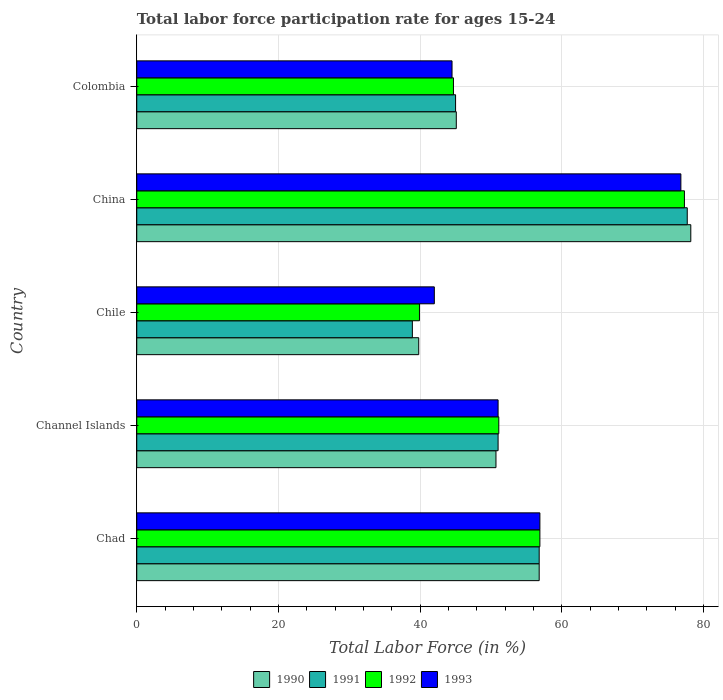How many different coloured bars are there?
Offer a terse response. 4. How many groups of bars are there?
Provide a succinct answer. 5. Are the number of bars per tick equal to the number of legend labels?
Provide a succinct answer. Yes. How many bars are there on the 4th tick from the top?
Offer a very short reply. 4. What is the label of the 5th group of bars from the top?
Ensure brevity in your answer.  Chad. What is the labor force participation rate in 1992 in Chad?
Make the answer very short. 56.9. Across all countries, what is the maximum labor force participation rate in 1991?
Provide a short and direct response. 77.7. Across all countries, what is the minimum labor force participation rate in 1992?
Your answer should be very brief. 39.9. In which country was the labor force participation rate in 1993 maximum?
Ensure brevity in your answer.  China. What is the total labor force participation rate in 1990 in the graph?
Make the answer very short. 270.6. What is the difference between the labor force participation rate in 1990 in Chad and that in Channel Islands?
Your answer should be compact. 6.1. What is the difference between the labor force participation rate in 1990 in Chad and the labor force participation rate in 1992 in Channel Islands?
Make the answer very short. 5.7. What is the average labor force participation rate in 1992 per country?
Your response must be concise. 53.98. What is the difference between the labor force participation rate in 1990 and labor force participation rate in 1992 in China?
Provide a succinct answer. 0.9. In how many countries, is the labor force participation rate in 1991 greater than 24 %?
Offer a terse response. 5. What is the ratio of the labor force participation rate in 1991 in Chad to that in Chile?
Ensure brevity in your answer.  1.46. Is the difference between the labor force participation rate in 1990 in Chile and China greater than the difference between the labor force participation rate in 1992 in Chile and China?
Give a very brief answer. No. What is the difference between the highest and the second highest labor force participation rate in 1991?
Keep it short and to the point. 20.9. What is the difference between the highest and the lowest labor force participation rate in 1991?
Your answer should be compact. 38.8. Is it the case that in every country, the sum of the labor force participation rate in 1990 and labor force participation rate in 1992 is greater than the sum of labor force participation rate in 1991 and labor force participation rate in 1993?
Give a very brief answer. No. What does the 2nd bar from the top in Colombia represents?
Your answer should be compact. 1992. What does the 1st bar from the bottom in Channel Islands represents?
Keep it short and to the point. 1990. How many bars are there?
Give a very brief answer. 20. Are all the bars in the graph horizontal?
Provide a short and direct response. Yes. How many countries are there in the graph?
Provide a short and direct response. 5. What is the difference between two consecutive major ticks on the X-axis?
Ensure brevity in your answer.  20. Does the graph contain grids?
Your answer should be compact. Yes. How many legend labels are there?
Offer a very short reply. 4. What is the title of the graph?
Give a very brief answer. Total labor force participation rate for ages 15-24. What is the Total Labor Force (in %) of 1990 in Chad?
Ensure brevity in your answer.  56.8. What is the Total Labor Force (in %) in 1991 in Chad?
Give a very brief answer. 56.8. What is the Total Labor Force (in %) of 1992 in Chad?
Provide a succinct answer. 56.9. What is the Total Labor Force (in %) of 1993 in Chad?
Ensure brevity in your answer.  56.9. What is the Total Labor Force (in %) of 1990 in Channel Islands?
Offer a very short reply. 50.7. What is the Total Labor Force (in %) in 1991 in Channel Islands?
Your response must be concise. 51. What is the Total Labor Force (in %) of 1992 in Channel Islands?
Ensure brevity in your answer.  51.1. What is the Total Labor Force (in %) of 1990 in Chile?
Your response must be concise. 39.8. What is the Total Labor Force (in %) in 1991 in Chile?
Offer a terse response. 38.9. What is the Total Labor Force (in %) of 1992 in Chile?
Your answer should be compact. 39.9. What is the Total Labor Force (in %) in 1993 in Chile?
Your answer should be compact. 42. What is the Total Labor Force (in %) in 1990 in China?
Offer a terse response. 78.2. What is the Total Labor Force (in %) of 1991 in China?
Your response must be concise. 77.7. What is the Total Labor Force (in %) in 1992 in China?
Ensure brevity in your answer.  77.3. What is the Total Labor Force (in %) of 1993 in China?
Offer a terse response. 76.8. What is the Total Labor Force (in %) in 1990 in Colombia?
Ensure brevity in your answer.  45.1. What is the Total Labor Force (in %) in 1991 in Colombia?
Offer a terse response. 45. What is the Total Labor Force (in %) of 1992 in Colombia?
Your answer should be compact. 44.7. What is the Total Labor Force (in %) of 1993 in Colombia?
Provide a short and direct response. 44.5. Across all countries, what is the maximum Total Labor Force (in %) in 1990?
Your answer should be compact. 78.2. Across all countries, what is the maximum Total Labor Force (in %) of 1991?
Your response must be concise. 77.7. Across all countries, what is the maximum Total Labor Force (in %) in 1992?
Make the answer very short. 77.3. Across all countries, what is the maximum Total Labor Force (in %) in 1993?
Your answer should be very brief. 76.8. Across all countries, what is the minimum Total Labor Force (in %) in 1990?
Your answer should be compact. 39.8. Across all countries, what is the minimum Total Labor Force (in %) of 1991?
Provide a succinct answer. 38.9. Across all countries, what is the minimum Total Labor Force (in %) of 1992?
Offer a very short reply. 39.9. What is the total Total Labor Force (in %) of 1990 in the graph?
Ensure brevity in your answer.  270.6. What is the total Total Labor Force (in %) in 1991 in the graph?
Provide a succinct answer. 269.4. What is the total Total Labor Force (in %) of 1992 in the graph?
Give a very brief answer. 269.9. What is the total Total Labor Force (in %) of 1993 in the graph?
Your response must be concise. 271.2. What is the difference between the Total Labor Force (in %) in 1990 in Chad and that in Channel Islands?
Provide a succinct answer. 6.1. What is the difference between the Total Labor Force (in %) in 1991 in Chad and that in Channel Islands?
Provide a short and direct response. 5.8. What is the difference between the Total Labor Force (in %) in 1992 in Chad and that in Channel Islands?
Your response must be concise. 5.8. What is the difference between the Total Labor Force (in %) in 1993 in Chad and that in Channel Islands?
Your answer should be compact. 5.9. What is the difference between the Total Labor Force (in %) of 1990 in Chad and that in Chile?
Your response must be concise. 17. What is the difference between the Total Labor Force (in %) in 1991 in Chad and that in Chile?
Keep it short and to the point. 17.9. What is the difference between the Total Labor Force (in %) in 1993 in Chad and that in Chile?
Offer a very short reply. 14.9. What is the difference between the Total Labor Force (in %) in 1990 in Chad and that in China?
Your answer should be very brief. -21.4. What is the difference between the Total Labor Force (in %) in 1991 in Chad and that in China?
Offer a terse response. -20.9. What is the difference between the Total Labor Force (in %) in 1992 in Chad and that in China?
Ensure brevity in your answer.  -20.4. What is the difference between the Total Labor Force (in %) in 1993 in Chad and that in China?
Provide a succinct answer. -19.9. What is the difference between the Total Labor Force (in %) in 1990 in Chad and that in Colombia?
Provide a short and direct response. 11.7. What is the difference between the Total Labor Force (in %) of 1992 in Chad and that in Colombia?
Provide a succinct answer. 12.2. What is the difference between the Total Labor Force (in %) of 1991 in Channel Islands and that in Chile?
Your response must be concise. 12.1. What is the difference between the Total Labor Force (in %) in 1992 in Channel Islands and that in Chile?
Ensure brevity in your answer.  11.2. What is the difference between the Total Labor Force (in %) of 1990 in Channel Islands and that in China?
Provide a succinct answer. -27.5. What is the difference between the Total Labor Force (in %) in 1991 in Channel Islands and that in China?
Your response must be concise. -26.7. What is the difference between the Total Labor Force (in %) in 1992 in Channel Islands and that in China?
Offer a very short reply. -26.2. What is the difference between the Total Labor Force (in %) in 1993 in Channel Islands and that in China?
Provide a succinct answer. -25.8. What is the difference between the Total Labor Force (in %) in 1991 in Channel Islands and that in Colombia?
Offer a terse response. 6. What is the difference between the Total Labor Force (in %) of 1992 in Channel Islands and that in Colombia?
Offer a very short reply. 6.4. What is the difference between the Total Labor Force (in %) of 1993 in Channel Islands and that in Colombia?
Keep it short and to the point. 6.5. What is the difference between the Total Labor Force (in %) in 1990 in Chile and that in China?
Provide a short and direct response. -38.4. What is the difference between the Total Labor Force (in %) of 1991 in Chile and that in China?
Keep it short and to the point. -38.8. What is the difference between the Total Labor Force (in %) of 1992 in Chile and that in China?
Give a very brief answer. -37.4. What is the difference between the Total Labor Force (in %) in 1993 in Chile and that in China?
Make the answer very short. -34.8. What is the difference between the Total Labor Force (in %) of 1992 in Chile and that in Colombia?
Give a very brief answer. -4.8. What is the difference between the Total Labor Force (in %) in 1990 in China and that in Colombia?
Your answer should be very brief. 33.1. What is the difference between the Total Labor Force (in %) in 1991 in China and that in Colombia?
Make the answer very short. 32.7. What is the difference between the Total Labor Force (in %) of 1992 in China and that in Colombia?
Give a very brief answer. 32.6. What is the difference between the Total Labor Force (in %) in 1993 in China and that in Colombia?
Make the answer very short. 32.3. What is the difference between the Total Labor Force (in %) in 1990 in Chad and the Total Labor Force (in %) in 1991 in Channel Islands?
Make the answer very short. 5.8. What is the difference between the Total Labor Force (in %) in 1990 in Chad and the Total Labor Force (in %) in 1992 in Channel Islands?
Offer a terse response. 5.7. What is the difference between the Total Labor Force (in %) of 1990 in Chad and the Total Labor Force (in %) of 1993 in Channel Islands?
Make the answer very short. 5.8. What is the difference between the Total Labor Force (in %) in 1991 in Chad and the Total Labor Force (in %) in 1992 in Channel Islands?
Your response must be concise. 5.7. What is the difference between the Total Labor Force (in %) in 1991 in Chad and the Total Labor Force (in %) in 1993 in Channel Islands?
Give a very brief answer. 5.8. What is the difference between the Total Labor Force (in %) in 1990 in Chad and the Total Labor Force (in %) in 1991 in Chile?
Make the answer very short. 17.9. What is the difference between the Total Labor Force (in %) in 1990 in Chad and the Total Labor Force (in %) in 1992 in Chile?
Offer a very short reply. 16.9. What is the difference between the Total Labor Force (in %) in 1991 in Chad and the Total Labor Force (in %) in 1993 in Chile?
Provide a short and direct response. 14.8. What is the difference between the Total Labor Force (in %) of 1992 in Chad and the Total Labor Force (in %) of 1993 in Chile?
Keep it short and to the point. 14.9. What is the difference between the Total Labor Force (in %) in 1990 in Chad and the Total Labor Force (in %) in 1991 in China?
Provide a short and direct response. -20.9. What is the difference between the Total Labor Force (in %) in 1990 in Chad and the Total Labor Force (in %) in 1992 in China?
Make the answer very short. -20.5. What is the difference between the Total Labor Force (in %) of 1991 in Chad and the Total Labor Force (in %) of 1992 in China?
Make the answer very short. -20.5. What is the difference between the Total Labor Force (in %) in 1992 in Chad and the Total Labor Force (in %) in 1993 in China?
Ensure brevity in your answer.  -19.9. What is the difference between the Total Labor Force (in %) in 1990 in Chad and the Total Labor Force (in %) in 1991 in Colombia?
Make the answer very short. 11.8. What is the difference between the Total Labor Force (in %) in 1990 in Chad and the Total Labor Force (in %) in 1993 in Colombia?
Your answer should be very brief. 12.3. What is the difference between the Total Labor Force (in %) of 1991 in Chad and the Total Labor Force (in %) of 1992 in Colombia?
Offer a very short reply. 12.1. What is the difference between the Total Labor Force (in %) in 1991 in Chad and the Total Labor Force (in %) in 1993 in Colombia?
Provide a succinct answer. 12.3. What is the difference between the Total Labor Force (in %) of 1990 in Channel Islands and the Total Labor Force (in %) of 1991 in Chile?
Keep it short and to the point. 11.8. What is the difference between the Total Labor Force (in %) of 1990 in Channel Islands and the Total Labor Force (in %) of 1992 in Chile?
Your answer should be very brief. 10.8. What is the difference between the Total Labor Force (in %) in 1991 in Channel Islands and the Total Labor Force (in %) in 1993 in Chile?
Ensure brevity in your answer.  9. What is the difference between the Total Labor Force (in %) of 1992 in Channel Islands and the Total Labor Force (in %) of 1993 in Chile?
Give a very brief answer. 9.1. What is the difference between the Total Labor Force (in %) of 1990 in Channel Islands and the Total Labor Force (in %) of 1991 in China?
Ensure brevity in your answer.  -27. What is the difference between the Total Labor Force (in %) of 1990 in Channel Islands and the Total Labor Force (in %) of 1992 in China?
Your response must be concise. -26.6. What is the difference between the Total Labor Force (in %) of 1990 in Channel Islands and the Total Labor Force (in %) of 1993 in China?
Give a very brief answer. -26.1. What is the difference between the Total Labor Force (in %) in 1991 in Channel Islands and the Total Labor Force (in %) in 1992 in China?
Offer a terse response. -26.3. What is the difference between the Total Labor Force (in %) in 1991 in Channel Islands and the Total Labor Force (in %) in 1993 in China?
Ensure brevity in your answer.  -25.8. What is the difference between the Total Labor Force (in %) of 1992 in Channel Islands and the Total Labor Force (in %) of 1993 in China?
Your answer should be compact. -25.7. What is the difference between the Total Labor Force (in %) in 1990 in Channel Islands and the Total Labor Force (in %) in 1992 in Colombia?
Your response must be concise. 6. What is the difference between the Total Labor Force (in %) of 1991 in Channel Islands and the Total Labor Force (in %) of 1992 in Colombia?
Provide a succinct answer. 6.3. What is the difference between the Total Labor Force (in %) in 1992 in Channel Islands and the Total Labor Force (in %) in 1993 in Colombia?
Your response must be concise. 6.6. What is the difference between the Total Labor Force (in %) in 1990 in Chile and the Total Labor Force (in %) in 1991 in China?
Provide a succinct answer. -37.9. What is the difference between the Total Labor Force (in %) in 1990 in Chile and the Total Labor Force (in %) in 1992 in China?
Offer a very short reply. -37.5. What is the difference between the Total Labor Force (in %) of 1990 in Chile and the Total Labor Force (in %) of 1993 in China?
Make the answer very short. -37. What is the difference between the Total Labor Force (in %) of 1991 in Chile and the Total Labor Force (in %) of 1992 in China?
Give a very brief answer. -38.4. What is the difference between the Total Labor Force (in %) of 1991 in Chile and the Total Labor Force (in %) of 1993 in China?
Provide a succinct answer. -37.9. What is the difference between the Total Labor Force (in %) in 1992 in Chile and the Total Labor Force (in %) in 1993 in China?
Provide a short and direct response. -36.9. What is the difference between the Total Labor Force (in %) in 1990 in Chile and the Total Labor Force (in %) in 1993 in Colombia?
Make the answer very short. -4.7. What is the difference between the Total Labor Force (in %) in 1991 in Chile and the Total Labor Force (in %) in 1993 in Colombia?
Provide a succinct answer. -5.6. What is the difference between the Total Labor Force (in %) in 1992 in Chile and the Total Labor Force (in %) in 1993 in Colombia?
Provide a short and direct response. -4.6. What is the difference between the Total Labor Force (in %) in 1990 in China and the Total Labor Force (in %) in 1991 in Colombia?
Your answer should be very brief. 33.2. What is the difference between the Total Labor Force (in %) of 1990 in China and the Total Labor Force (in %) of 1992 in Colombia?
Offer a very short reply. 33.5. What is the difference between the Total Labor Force (in %) in 1990 in China and the Total Labor Force (in %) in 1993 in Colombia?
Give a very brief answer. 33.7. What is the difference between the Total Labor Force (in %) in 1991 in China and the Total Labor Force (in %) in 1992 in Colombia?
Your answer should be very brief. 33. What is the difference between the Total Labor Force (in %) in 1991 in China and the Total Labor Force (in %) in 1993 in Colombia?
Provide a short and direct response. 33.2. What is the difference between the Total Labor Force (in %) in 1992 in China and the Total Labor Force (in %) in 1993 in Colombia?
Provide a succinct answer. 32.8. What is the average Total Labor Force (in %) of 1990 per country?
Your answer should be compact. 54.12. What is the average Total Labor Force (in %) of 1991 per country?
Your answer should be very brief. 53.88. What is the average Total Labor Force (in %) in 1992 per country?
Your answer should be very brief. 53.98. What is the average Total Labor Force (in %) in 1993 per country?
Your answer should be very brief. 54.24. What is the difference between the Total Labor Force (in %) of 1990 and Total Labor Force (in %) of 1991 in Chad?
Give a very brief answer. 0. What is the difference between the Total Labor Force (in %) in 1990 and Total Labor Force (in %) in 1993 in Chad?
Your response must be concise. -0.1. What is the difference between the Total Labor Force (in %) of 1991 and Total Labor Force (in %) of 1992 in Chad?
Your answer should be compact. -0.1. What is the difference between the Total Labor Force (in %) in 1992 and Total Labor Force (in %) in 1993 in Chad?
Offer a terse response. 0. What is the difference between the Total Labor Force (in %) in 1990 and Total Labor Force (in %) in 1991 in Channel Islands?
Provide a short and direct response. -0.3. What is the difference between the Total Labor Force (in %) in 1990 and Total Labor Force (in %) in 1993 in Channel Islands?
Your response must be concise. -0.3. What is the difference between the Total Labor Force (in %) in 1991 and Total Labor Force (in %) in 1993 in Channel Islands?
Provide a short and direct response. 0. What is the difference between the Total Labor Force (in %) of 1992 and Total Labor Force (in %) of 1993 in Channel Islands?
Give a very brief answer. 0.1. What is the difference between the Total Labor Force (in %) in 1990 and Total Labor Force (in %) in 1991 in Chile?
Your answer should be compact. 0.9. What is the difference between the Total Labor Force (in %) in 1990 and Total Labor Force (in %) in 1992 in Chile?
Ensure brevity in your answer.  -0.1. What is the difference between the Total Labor Force (in %) in 1991 and Total Labor Force (in %) in 1993 in Chile?
Provide a short and direct response. -3.1. What is the difference between the Total Labor Force (in %) of 1990 and Total Labor Force (in %) of 1992 in China?
Provide a succinct answer. 0.9. What is the difference between the Total Labor Force (in %) of 1990 and Total Labor Force (in %) of 1993 in China?
Make the answer very short. 1.4. What is the difference between the Total Labor Force (in %) of 1992 and Total Labor Force (in %) of 1993 in China?
Your response must be concise. 0.5. What is the difference between the Total Labor Force (in %) of 1990 and Total Labor Force (in %) of 1991 in Colombia?
Make the answer very short. 0.1. What is the difference between the Total Labor Force (in %) of 1992 and Total Labor Force (in %) of 1993 in Colombia?
Your answer should be compact. 0.2. What is the ratio of the Total Labor Force (in %) in 1990 in Chad to that in Channel Islands?
Ensure brevity in your answer.  1.12. What is the ratio of the Total Labor Force (in %) of 1991 in Chad to that in Channel Islands?
Your answer should be very brief. 1.11. What is the ratio of the Total Labor Force (in %) of 1992 in Chad to that in Channel Islands?
Make the answer very short. 1.11. What is the ratio of the Total Labor Force (in %) in 1993 in Chad to that in Channel Islands?
Ensure brevity in your answer.  1.12. What is the ratio of the Total Labor Force (in %) of 1990 in Chad to that in Chile?
Provide a short and direct response. 1.43. What is the ratio of the Total Labor Force (in %) of 1991 in Chad to that in Chile?
Provide a short and direct response. 1.46. What is the ratio of the Total Labor Force (in %) of 1992 in Chad to that in Chile?
Offer a very short reply. 1.43. What is the ratio of the Total Labor Force (in %) of 1993 in Chad to that in Chile?
Offer a terse response. 1.35. What is the ratio of the Total Labor Force (in %) of 1990 in Chad to that in China?
Provide a succinct answer. 0.73. What is the ratio of the Total Labor Force (in %) in 1991 in Chad to that in China?
Your answer should be compact. 0.73. What is the ratio of the Total Labor Force (in %) in 1992 in Chad to that in China?
Provide a short and direct response. 0.74. What is the ratio of the Total Labor Force (in %) in 1993 in Chad to that in China?
Give a very brief answer. 0.74. What is the ratio of the Total Labor Force (in %) of 1990 in Chad to that in Colombia?
Provide a succinct answer. 1.26. What is the ratio of the Total Labor Force (in %) in 1991 in Chad to that in Colombia?
Your answer should be compact. 1.26. What is the ratio of the Total Labor Force (in %) of 1992 in Chad to that in Colombia?
Your answer should be very brief. 1.27. What is the ratio of the Total Labor Force (in %) of 1993 in Chad to that in Colombia?
Your response must be concise. 1.28. What is the ratio of the Total Labor Force (in %) of 1990 in Channel Islands to that in Chile?
Your answer should be compact. 1.27. What is the ratio of the Total Labor Force (in %) in 1991 in Channel Islands to that in Chile?
Provide a short and direct response. 1.31. What is the ratio of the Total Labor Force (in %) of 1992 in Channel Islands to that in Chile?
Your answer should be very brief. 1.28. What is the ratio of the Total Labor Force (in %) of 1993 in Channel Islands to that in Chile?
Give a very brief answer. 1.21. What is the ratio of the Total Labor Force (in %) of 1990 in Channel Islands to that in China?
Provide a short and direct response. 0.65. What is the ratio of the Total Labor Force (in %) of 1991 in Channel Islands to that in China?
Make the answer very short. 0.66. What is the ratio of the Total Labor Force (in %) in 1992 in Channel Islands to that in China?
Offer a very short reply. 0.66. What is the ratio of the Total Labor Force (in %) in 1993 in Channel Islands to that in China?
Offer a terse response. 0.66. What is the ratio of the Total Labor Force (in %) in 1990 in Channel Islands to that in Colombia?
Provide a short and direct response. 1.12. What is the ratio of the Total Labor Force (in %) of 1991 in Channel Islands to that in Colombia?
Offer a terse response. 1.13. What is the ratio of the Total Labor Force (in %) of 1992 in Channel Islands to that in Colombia?
Provide a succinct answer. 1.14. What is the ratio of the Total Labor Force (in %) in 1993 in Channel Islands to that in Colombia?
Give a very brief answer. 1.15. What is the ratio of the Total Labor Force (in %) of 1990 in Chile to that in China?
Your answer should be very brief. 0.51. What is the ratio of the Total Labor Force (in %) in 1991 in Chile to that in China?
Provide a short and direct response. 0.5. What is the ratio of the Total Labor Force (in %) in 1992 in Chile to that in China?
Offer a very short reply. 0.52. What is the ratio of the Total Labor Force (in %) of 1993 in Chile to that in China?
Your answer should be very brief. 0.55. What is the ratio of the Total Labor Force (in %) of 1990 in Chile to that in Colombia?
Your answer should be compact. 0.88. What is the ratio of the Total Labor Force (in %) of 1991 in Chile to that in Colombia?
Your answer should be very brief. 0.86. What is the ratio of the Total Labor Force (in %) of 1992 in Chile to that in Colombia?
Your response must be concise. 0.89. What is the ratio of the Total Labor Force (in %) of 1993 in Chile to that in Colombia?
Ensure brevity in your answer.  0.94. What is the ratio of the Total Labor Force (in %) of 1990 in China to that in Colombia?
Your answer should be very brief. 1.73. What is the ratio of the Total Labor Force (in %) of 1991 in China to that in Colombia?
Keep it short and to the point. 1.73. What is the ratio of the Total Labor Force (in %) in 1992 in China to that in Colombia?
Provide a succinct answer. 1.73. What is the ratio of the Total Labor Force (in %) of 1993 in China to that in Colombia?
Offer a very short reply. 1.73. What is the difference between the highest and the second highest Total Labor Force (in %) in 1990?
Give a very brief answer. 21.4. What is the difference between the highest and the second highest Total Labor Force (in %) in 1991?
Keep it short and to the point. 20.9. What is the difference between the highest and the second highest Total Labor Force (in %) in 1992?
Your response must be concise. 20.4. What is the difference between the highest and the second highest Total Labor Force (in %) of 1993?
Provide a succinct answer. 19.9. What is the difference between the highest and the lowest Total Labor Force (in %) in 1990?
Give a very brief answer. 38.4. What is the difference between the highest and the lowest Total Labor Force (in %) in 1991?
Keep it short and to the point. 38.8. What is the difference between the highest and the lowest Total Labor Force (in %) of 1992?
Keep it short and to the point. 37.4. What is the difference between the highest and the lowest Total Labor Force (in %) in 1993?
Your response must be concise. 34.8. 